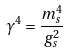<formula> <loc_0><loc_0><loc_500><loc_500>\gamma ^ { 4 } = \frac { m _ { s } ^ { 4 } } { g _ { s } ^ { 2 } }</formula> 